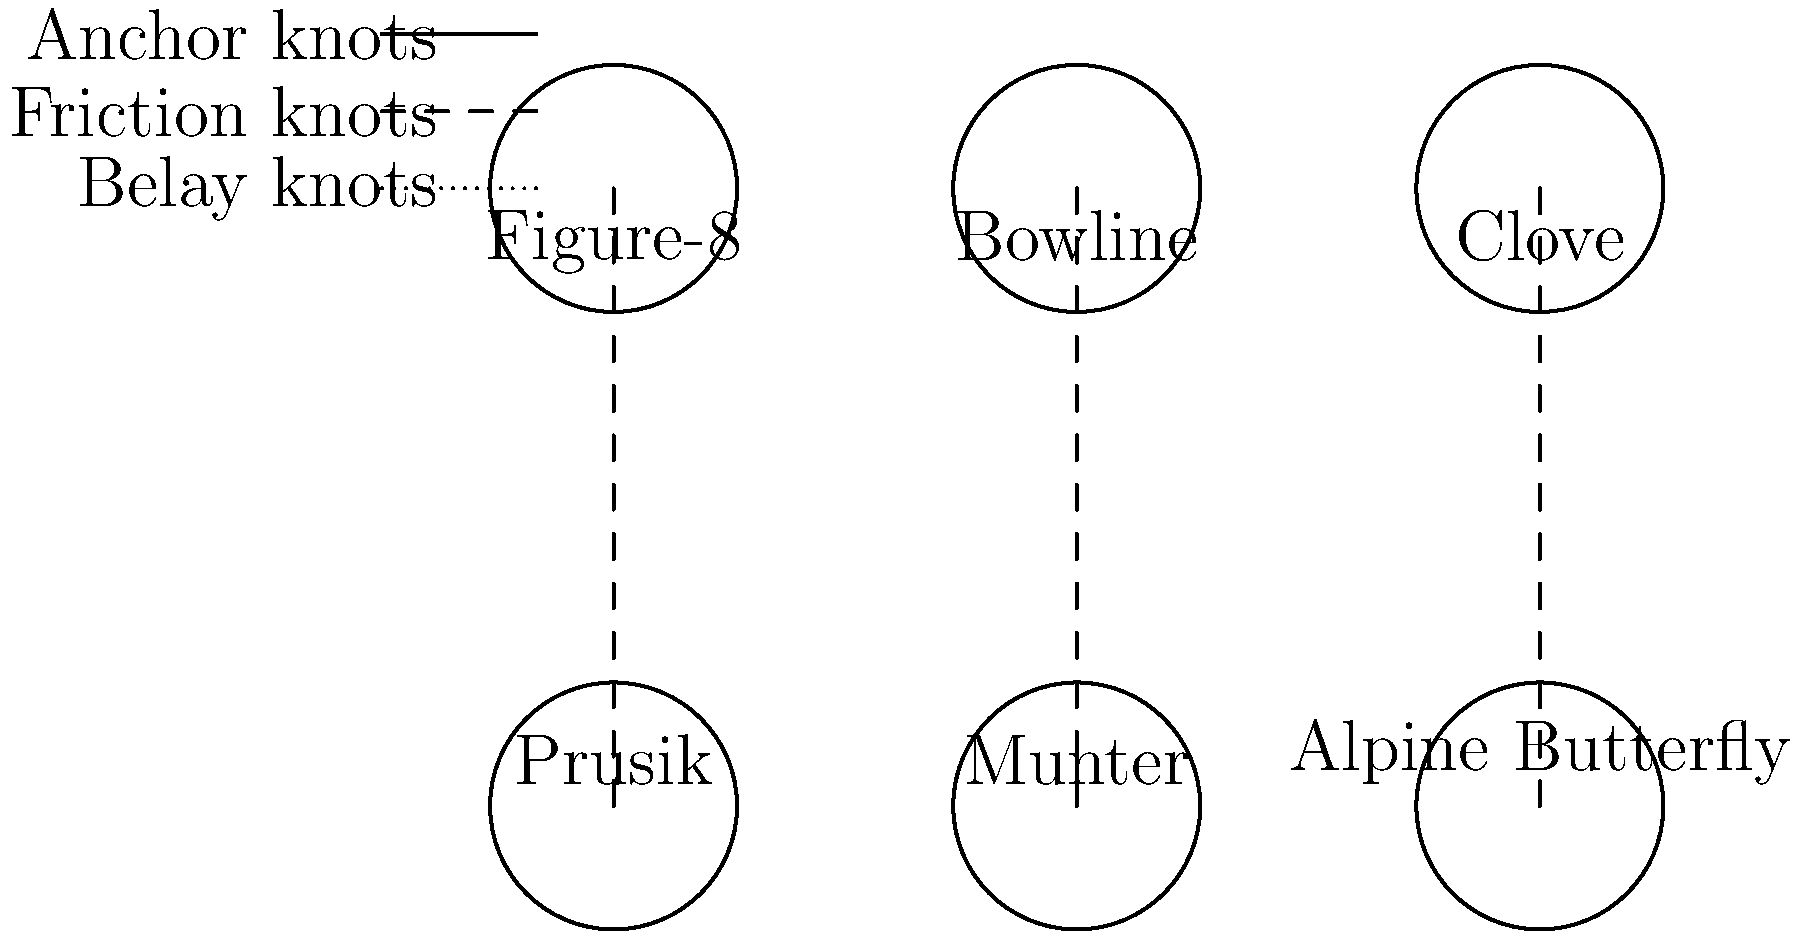Based on the diagram, which knot would be most suitable for creating a mid-line loop in a climbing rope to attach a carabiner for an intermediate anchor point? To determine the most suitable knot for creating a mid-line loop in a climbing rope, let's analyze each knot's characteristics and applications:

1. Figure-8: Primarily used for tying into harnesses or creating end-of-rope anchors. Not ideal for mid-line loops.

2. Bowline: Commonly used for tying into harnesses or creating end-of-rope loops. Not suitable for mid-line applications.

3. Clove hitch: Used for attaching ropes to carabiners or anchors. Not designed for creating loops.

4. Prusik: A friction hitch used for ascending ropes or as a backup. Not suitable for creating a stable mid-line loop.

5. Munter hitch: Used for belaying, not for creating loops.

6. Alpine Butterfly: Specifically designed for creating a secure mid-line loop that can be loaded in multiple directions. It maintains its strength and is easy to untie even after being loaded.

Given these characteristics, the Alpine Butterfly knot is the most suitable option for creating a mid-line loop in a climbing rope to attach a carabiner for an intermediate anchor point. It provides a strong, stable loop that can be safely loaded in various directions, making it ideal for this application in mountaineering.
Answer: Alpine Butterfly knot 